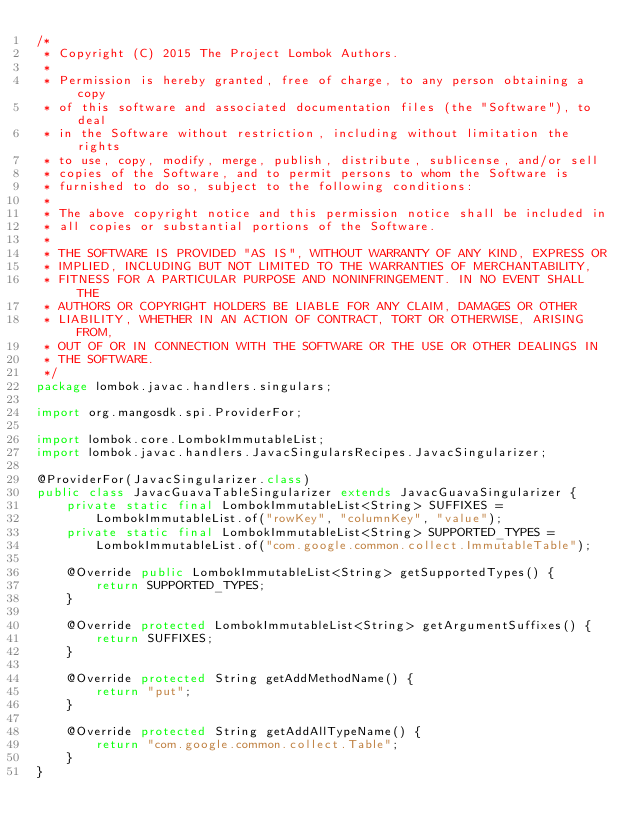Convert code to text. <code><loc_0><loc_0><loc_500><loc_500><_Java_>/*
 * Copyright (C) 2015 The Project Lombok Authors.
 * 
 * Permission is hereby granted, free of charge, to any person obtaining a copy
 * of this software and associated documentation files (the "Software"), to deal
 * in the Software without restriction, including without limitation the rights
 * to use, copy, modify, merge, publish, distribute, sublicense, and/or sell
 * copies of the Software, and to permit persons to whom the Software is
 * furnished to do so, subject to the following conditions:
 * 
 * The above copyright notice and this permission notice shall be included in
 * all copies or substantial portions of the Software.
 * 
 * THE SOFTWARE IS PROVIDED "AS IS", WITHOUT WARRANTY OF ANY KIND, EXPRESS OR
 * IMPLIED, INCLUDING BUT NOT LIMITED TO THE WARRANTIES OF MERCHANTABILITY,
 * FITNESS FOR A PARTICULAR PURPOSE AND NONINFRINGEMENT. IN NO EVENT SHALL THE
 * AUTHORS OR COPYRIGHT HOLDERS BE LIABLE FOR ANY CLAIM, DAMAGES OR OTHER
 * LIABILITY, WHETHER IN AN ACTION OF CONTRACT, TORT OR OTHERWISE, ARISING FROM,
 * OUT OF OR IN CONNECTION WITH THE SOFTWARE OR THE USE OR OTHER DEALINGS IN
 * THE SOFTWARE.
 */
package lombok.javac.handlers.singulars;

import org.mangosdk.spi.ProviderFor;

import lombok.core.LombokImmutableList;
import lombok.javac.handlers.JavacSingularsRecipes.JavacSingularizer;

@ProviderFor(JavacSingularizer.class)
public class JavacGuavaTableSingularizer extends JavacGuavaSingularizer {
	private static final LombokImmutableList<String> SUFFIXES =
		LombokImmutableList.of("rowKey", "columnKey", "value");
	private static final LombokImmutableList<String> SUPPORTED_TYPES =
		LombokImmutableList.of("com.google.common.collect.ImmutableTable");
	
	@Override public LombokImmutableList<String> getSupportedTypes() {
		return SUPPORTED_TYPES;
	}
	
	@Override protected LombokImmutableList<String> getArgumentSuffixes() {
		return SUFFIXES;
	}
	
	@Override protected String getAddMethodName() {
		return "put";
	}
	
	@Override protected String getAddAllTypeName() {
		return "com.google.common.collect.Table";
	}
}
</code> 